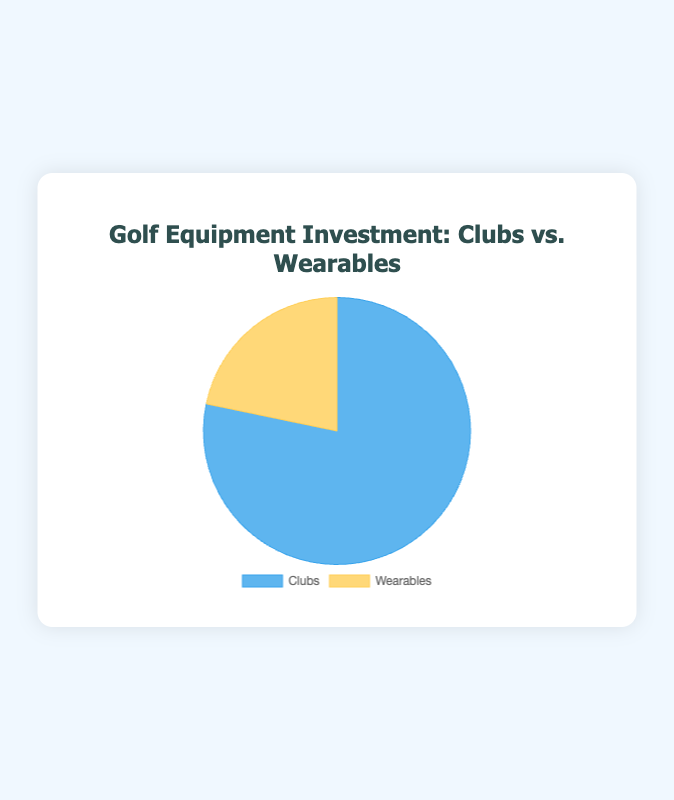What are the total investments in Clubs and Wearables? To find the total investment in each category, sum up all the values under "Clubs" and "Wearables" respectively. The total for "Clubs" is 500 (Drivers) + 800 (Irons) + 300 (Wedges) + 200 (Putters) = 1800. The total for "Wearables" is 150 (Tracking Devices) + 250 (Smartwatches) + 100 (Performance Monitors) = 500.
Answer: Clubs: 1800, Wearables: 500 Which type of equipment has a higher total investment, Clubs or Wearables? Compare the total investment for "Clubs" and "Wearables". "Clubs" has a total of 1800, while "Wearables" has a total of 500. Since 1800 is greater than 500, Clubs have a higher total investment.
Answer: Clubs What percentage of the total investment is in Wearables? To find the percentage, divide the total investment in Wearables by the total investment in both categories and multiply by 100. Total investment is 1800 (Clubs) + 500 (Wearables) = 2300. So, the percentage is (500 / 2300) * 100 ≈ 21.74%.
Answer: 21.74% How much more is invested in Clubs compared to Wearables? To find the difference, subtract the total investment in Wearables from the total investment in Clubs. The total for Clubs is 1800, and for Wearables, it is 500. Therefore, the difference is 1800 - 500 = 1300.
Answer: 1300 If the total investment were to increase by 10% evenly across both categories, what would be the new total investment? A 10% increase means each category's investment increases by 10% of its current value. For Clubs: 1800 + (0.10 * 1800) = 1800 + 180 = 1980. For Wearables: 500 + (0.10 * 500) = 500 + 50 = 550. The new total investment is 1980 + 550 = 2530.
Answer: 2530 What colors represent Clubs and Wearables in the pie chart? By observing the pie chart's legend, we can see that Clubs are represented by blue, and Wearables are represented by yellow.
Answer: Clubs: blue, Wearables: yellow What is the ratio of investment between Clubs and Wearables? To find the ratio, divide the total investment in Clubs by the total investment in Wearables. The total for Clubs is 1800, and for Wearables, it is 500. The ratio is 1800 / 500 = 3.6.
Answer: 3.6 What is the average amount invested in each of the Wearables categories? To find the average, sum up all the investments in Wearables and divide by the number of categories. The total is 150 (Tracking Devices) + 250 (Smartwatches) + 100 (Performance Monitors) = 500. There are 3 categories, so the average is 500 / 3 ≈ 166.67.
Answer: 166.67 